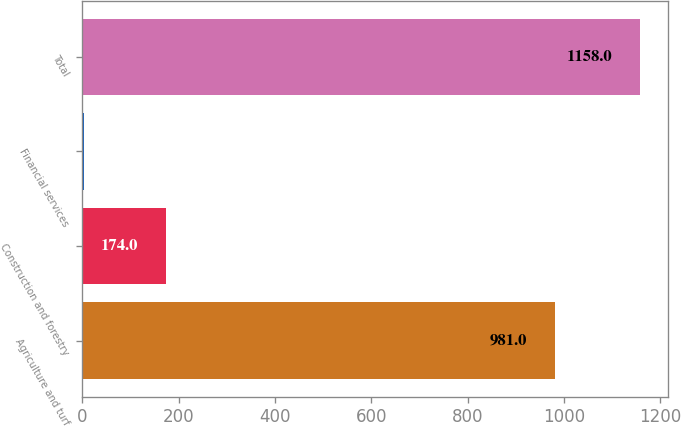Convert chart to OTSL. <chart><loc_0><loc_0><loc_500><loc_500><bar_chart><fcel>Agriculture and turf<fcel>Construction and forestry<fcel>Financial services<fcel>Total<nl><fcel>981<fcel>174<fcel>3<fcel>1158<nl></chart> 